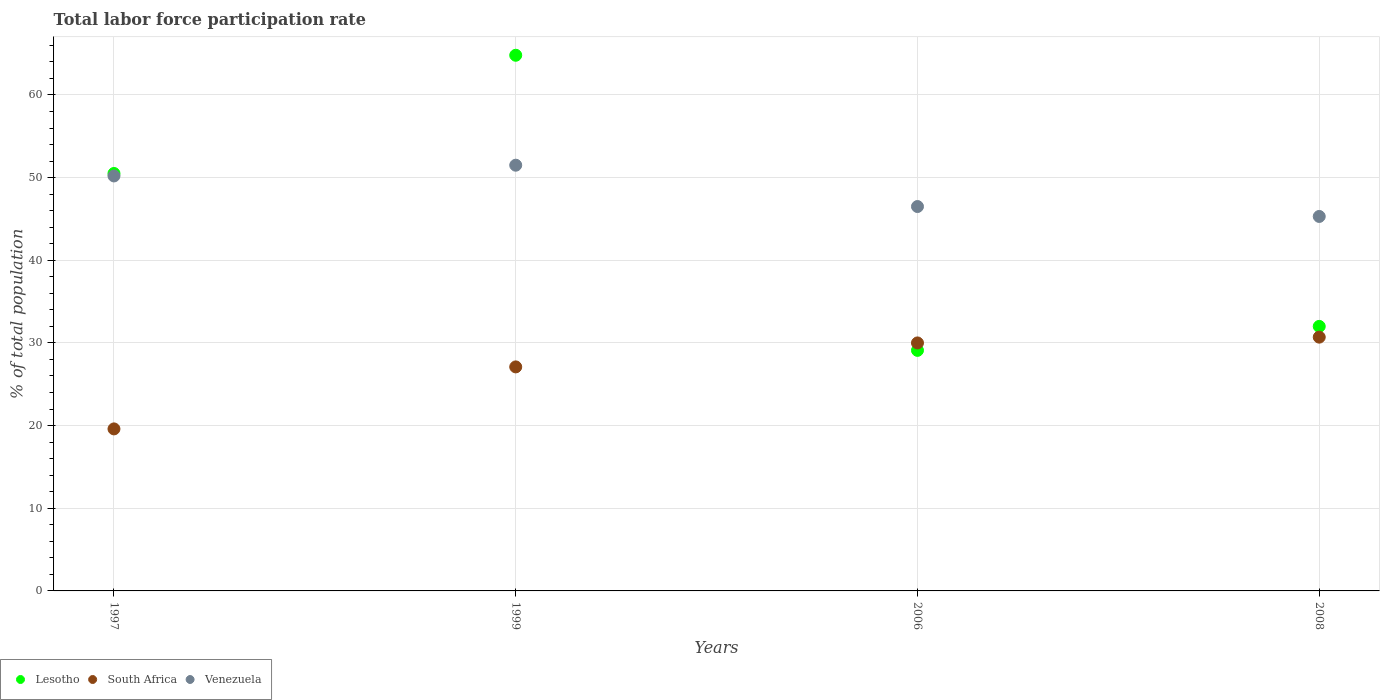How many different coloured dotlines are there?
Ensure brevity in your answer.  3. Is the number of dotlines equal to the number of legend labels?
Your response must be concise. Yes. What is the total labor force participation rate in Venezuela in 2008?
Offer a terse response. 45.3. Across all years, what is the maximum total labor force participation rate in Lesotho?
Provide a succinct answer. 64.8. Across all years, what is the minimum total labor force participation rate in South Africa?
Give a very brief answer. 19.6. In which year was the total labor force participation rate in Lesotho maximum?
Keep it short and to the point. 1999. In which year was the total labor force participation rate in Venezuela minimum?
Offer a very short reply. 2008. What is the total total labor force participation rate in Venezuela in the graph?
Keep it short and to the point. 193.5. What is the difference between the total labor force participation rate in South Africa in 1997 and that in 2008?
Make the answer very short. -11.1. What is the difference between the total labor force participation rate in South Africa in 1999 and the total labor force participation rate in Venezuela in 2008?
Your answer should be compact. -18.2. What is the average total labor force participation rate in South Africa per year?
Your answer should be very brief. 26.85. In the year 1999, what is the difference between the total labor force participation rate in Venezuela and total labor force participation rate in Lesotho?
Provide a short and direct response. -13.3. What is the ratio of the total labor force participation rate in Lesotho in 2006 to that in 2008?
Give a very brief answer. 0.91. What is the difference between the highest and the second highest total labor force participation rate in Lesotho?
Provide a succinct answer. 14.3. What is the difference between the highest and the lowest total labor force participation rate in South Africa?
Your response must be concise. 11.1. Is the sum of the total labor force participation rate in South Africa in 1997 and 2006 greater than the maximum total labor force participation rate in Venezuela across all years?
Keep it short and to the point. No. Is it the case that in every year, the sum of the total labor force participation rate in Lesotho and total labor force participation rate in Venezuela  is greater than the total labor force participation rate in South Africa?
Provide a short and direct response. Yes. How many dotlines are there?
Give a very brief answer. 3. How many years are there in the graph?
Your answer should be very brief. 4. Are the values on the major ticks of Y-axis written in scientific E-notation?
Offer a terse response. No. Does the graph contain grids?
Provide a short and direct response. Yes. Where does the legend appear in the graph?
Offer a very short reply. Bottom left. How many legend labels are there?
Provide a succinct answer. 3. How are the legend labels stacked?
Give a very brief answer. Horizontal. What is the title of the graph?
Offer a very short reply. Total labor force participation rate. Does "China" appear as one of the legend labels in the graph?
Offer a terse response. No. What is the label or title of the X-axis?
Offer a very short reply. Years. What is the label or title of the Y-axis?
Give a very brief answer. % of total population. What is the % of total population in Lesotho in 1997?
Offer a terse response. 50.5. What is the % of total population in South Africa in 1997?
Offer a terse response. 19.6. What is the % of total population of Venezuela in 1997?
Ensure brevity in your answer.  50.2. What is the % of total population of Lesotho in 1999?
Offer a very short reply. 64.8. What is the % of total population of South Africa in 1999?
Give a very brief answer. 27.1. What is the % of total population of Venezuela in 1999?
Your answer should be very brief. 51.5. What is the % of total population in Lesotho in 2006?
Your answer should be compact. 29.1. What is the % of total population of Venezuela in 2006?
Give a very brief answer. 46.5. What is the % of total population of South Africa in 2008?
Make the answer very short. 30.7. What is the % of total population in Venezuela in 2008?
Make the answer very short. 45.3. Across all years, what is the maximum % of total population of Lesotho?
Offer a terse response. 64.8. Across all years, what is the maximum % of total population in South Africa?
Your answer should be very brief. 30.7. Across all years, what is the maximum % of total population of Venezuela?
Offer a terse response. 51.5. Across all years, what is the minimum % of total population of Lesotho?
Ensure brevity in your answer.  29.1. Across all years, what is the minimum % of total population in South Africa?
Your response must be concise. 19.6. Across all years, what is the minimum % of total population in Venezuela?
Make the answer very short. 45.3. What is the total % of total population of Lesotho in the graph?
Offer a terse response. 176.4. What is the total % of total population in South Africa in the graph?
Your answer should be compact. 107.4. What is the total % of total population in Venezuela in the graph?
Keep it short and to the point. 193.5. What is the difference between the % of total population in Lesotho in 1997 and that in 1999?
Provide a succinct answer. -14.3. What is the difference between the % of total population of Lesotho in 1997 and that in 2006?
Ensure brevity in your answer.  21.4. What is the difference between the % of total population of Lesotho in 1997 and that in 2008?
Give a very brief answer. 18.5. What is the difference between the % of total population of Lesotho in 1999 and that in 2006?
Keep it short and to the point. 35.7. What is the difference between the % of total population in South Africa in 1999 and that in 2006?
Provide a succinct answer. -2.9. What is the difference between the % of total population in Lesotho in 1999 and that in 2008?
Provide a short and direct response. 32.8. What is the difference between the % of total population in South Africa in 2006 and that in 2008?
Keep it short and to the point. -0.7. What is the difference between the % of total population of Venezuela in 2006 and that in 2008?
Your response must be concise. 1.2. What is the difference between the % of total population in Lesotho in 1997 and the % of total population in South Africa in 1999?
Your answer should be very brief. 23.4. What is the difference between the % of total population of South Africa in 1997 and the % of total population of Venezuela in 1999?
Provide a succinct answer. -31.9. What is the difference between the % of total population of Lesotho in 1997 and the % of total population of South Africa in 2006?
Make the answer very short. 20.5. What is the difference between the % of total population of South Africa in 1997 and the % of total population of Venezuela in 2006?
Your answer should be compact. -26.9. What is the difference between the % of total population of Lesotho in 1997 and the % of total population of South Africa in 2008?
Offer a terse response. 19.8. What is the difference between the % of total population of South Africa in 1997 and the % of total population of Venezuela in 2008?
Your answer should be compact. -25.7. What is the difference between the % of total population of Lesotho in 1999 and the % of total population of South Africa in 2006?
Keep it short and to the point. 34.8. What is the difference between the % of total population of South Africa in 1999 and the % of total population of Venezuela in 2006?
Your answer should be compact. -19.4. What is the difference between the % of total population of Lesotho in 1999 and the % of total population of South Africa in 2008?
Offer a very short reply. 34.1. What is the difference between the % of total population of Lesotho in 1999 and the % of total population of Venezuela in 2008?
Provide a succinct answer. 19.5. What is the difference between the % of total population of South Africa in 1999 and the % of total population of Venezuela in 2008?
Provide a succinct answer. -18.2. What is the difference between the % of total population of Lesotho in 2006 and the % of total population of South Africa in 2008?
Your answer should be very brief. -1.6. What is the difference between the % of total population in Lesotho in 2006 and the % of total population in Venezuela in 2008?
Make the answer very short. -16.2. What is the difference between the % of total population in South Africa in 2006 and the % of total population in Venezuela in 2008?
Ensure brevity in your answer.  -15.3. What is the average % of total population of Lesotho per year?
Your answer should be very brief. 44.1. What is the average % of total population of South Africa per year?
Provide a short and direct response. 26.85. What is the average % of total population in Venezuela per year?
Your answer should be very brief. 48.38. In the year 1997, what is the difference between the % of total population in Lesotho and % of total population in South Africa?
Make the answer very short. 30.9. In the year 1997, what is the difference between the % of total population in Lesotho and % of total population in Venezuela?
Provide a succinct answer. 0.3. In the year 1997, what is the difference between the % of total population of South Africa and % of total population of Venezuela?
Offer a very short reply. -30.6. In the year 1999, what is the difference between the % of total population of Lesotho and % of total population of South Africa?
Make the answer very short. 37.7. In the year 1999, what is the difference between the % of total population in Lesotho and % of total population in Venezuela?
Your answer should be very brief. 13.3. In the year 1999, what is the difference between the % of total population in South Africa and % of total population in Venezuela?
Ensure brevity in your answer.  -24.4. In the year 2006, what is the difference between the % of total population of Lesotho and % of total population of South Africa?
Keep it short and to the point. -0.9. In the year 2006, what is the difference between the % of total population of Lesotho and % of total population of Venezuela?
Ensure brevity in your answer.  -17.4. In the year 2006, what is the difference between the % of total population in South Africa and % of total population in Venezuela?
Ensure brevity in your answer.  -16.5. In the year 2008, what is the difference between the % of total population in South Africa and % of total population in Venezuela?
Your answer should be very brief. -14.6. What is the ratio of the % of total population in Lesotho in 1997 to that in 1999?
Make the answer very short. 0.78. What is the ratio of the % of total population in South Africa in 1997 to that in 1999?
Offer a very short reply. 0.72. What is the ratio of the % of total population in Venezuela in 1997 to that in 1999?
Keep it short and to the point. 0.97. What is the ratio of the % of total population in Lesotho in 1997 to that in 2006?
Your answer should be very brief. 1.74. What is the ratio of the % of total population in South Africa in 1997 to that in 2006?
Your answer should be very brief. 0.65. What is the ratio of the % of total population in Venezuela in 1997 to that in 2006?
Make the answer very short. 1.08. What is the ratio of the % of total population of Lesotho in 1997 to that in 2008?
Offer a terse response. 1.58. What is the ratio of the % of total population of South Africa in 1997 to that in 2008?
Offer a very short reply. 0.64. What is the ratio of the % of total population in Venezuela in 1997 to that in 2008?
Make the answer very short. 1.11. What is the ratio of the % of total population in Lesotho in 1999 to that in 2006?
Keep it short and to the point. 2.23. What is the ratio of the % of total population of South Africa in 1999 to that in 2006?
Offer a very short reply. 0.9. What is the ratio of the % of total population in Venezuela in 1999 to that in 2006?
Ensure brevity in your answer.  1.11. What is the ratio of the % of total population of Lesotho in 1999 to that in 2008?
Keep it short and to the point. 2.02. What is the ratio of the % of total population in South Africa in 1999 to that in 2008?
Provide a succinct answer. 0.88. What is the ratio of the % of total population in Venezuela in 1999 to that in 2008?
Provide a succinct answer. 1.14. What is the ratio of the % of total population of Lesotho in 2006 to that in 2008?
Your answer should be compact. 0.91. What is the ratio of the % of total population in South Africa in 2006 to that in 2008?
Offer a terse response. 0.98. What is the ratio of the % of total population of Venezuela in 2006 to that in 2008?
Your answer should be very brief. 1.03. What is the difference between the highest and the lowest % of total population of Lesotho?
Make the answer very short. 35.7. What is the difference between the highest and the lowest % of total population of South Africa?
Ensure brevity in your answer.  11.1. 